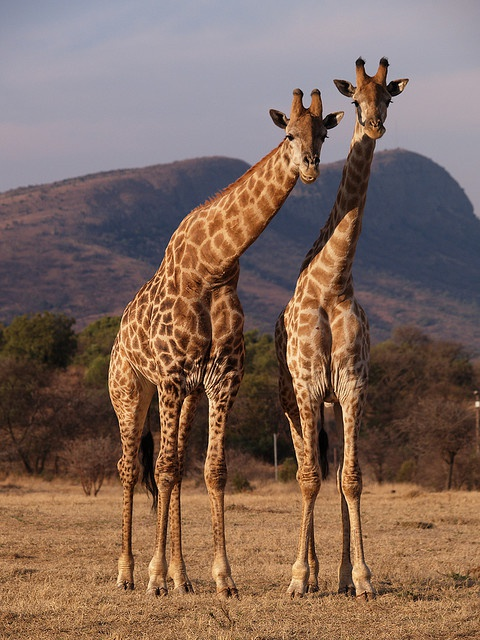Describe the objects in this image and their specific colors. I can see giraffe in gray, brown, tan, maroon, and black tones and giraffe in gray, black, maroon, tan, and brown tones in this image. 